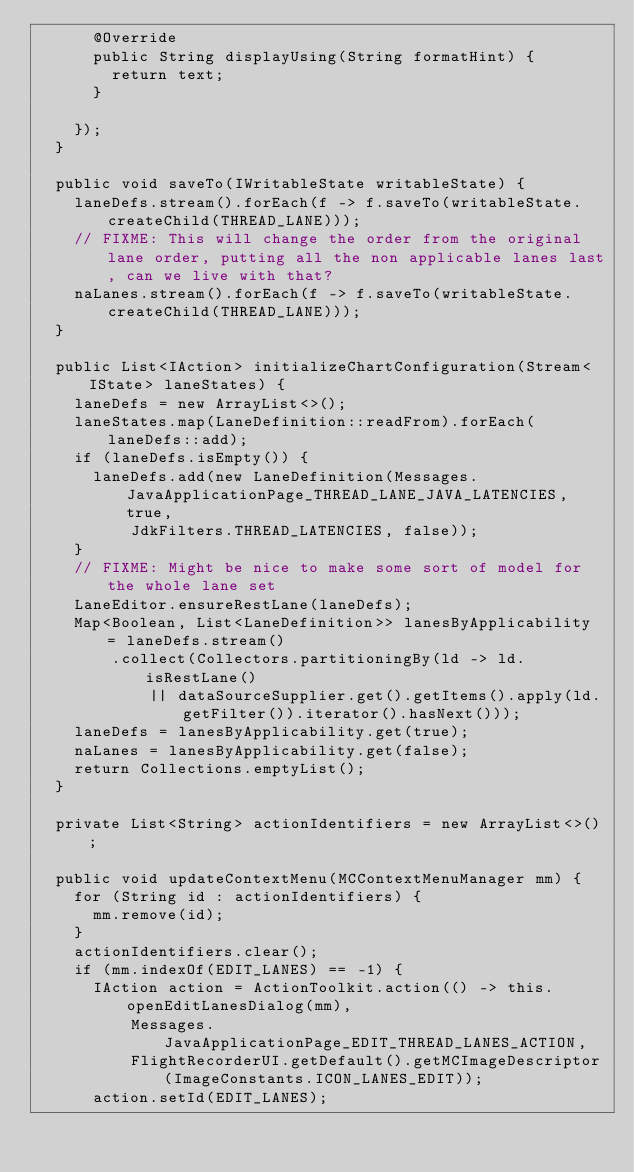<code> <loc_0><loc_0><loc_500><loc_500><_Java_>			@Override
			public String displayUsing(String formatHint) {
				return text;
			}

		});
	}

	public void saveTo(IWritableState writableState) {
		laneDefs.stream().forEach(f -> f.saveTo(writableState.createChild(THREAD_LANE)));
		// FIXME: This will change the order from the original lane order, putting all the non applicable lanes last, can we live with that?
		naLanes.stream().forEach(f -> f.saveTo(writableState.createChild(THREAD_LANE)));
	}

	public List<IAction> initializeChartConfiguration(Stream<IState> laneStates) {
		laneDefs = new ArrayList<>();
		laneStates.map(LaneDefinition::readFrom).forEach(laneDefs::add);
		if (laneDefs.isEmpty()) {
			laneDefs.add(new LaneDefinition(Messages.JavaApplicationPage_THREAD_LANE_JAVA_LATENCIES, true,
					JdkFilters.THREAD_LATENCIES, false));
		}
		// FIXME: Might be nice to make some sort of model for the whole lane set
		LaneEditor.ensureRestLane(laneDefs);
		Map<Boolean, List<LaneDefinition>> lanesByApplicability = laneDefs.stream()
				.collect(Collectors.partitioningBy(ld -> ld.isRestLane()
						|| dataSourceSupplier.get().getItems().apply(ld.getFilter()).iterator().hasNext()));
		laneDefs = lanesByApplicability.get(true);
		naLanes = lanesByApplicability.get(false);
		return Collections.emptyList();
	}

	private List<String> actionIdentifiers = new ArrayList<>();

	public void updateContextMenu(MCContextMenuManager mm) {
		for (String id : actionIdentifiers) {
			mm.remove(id);
		}
		actionIdentifiers.clear();
		if (mm.indexOf(EDIT_LANES) == -1) {
			IAction action = ActionToolkit.action(() -> this.openEditLanesDialog(mm),
					Messages.JavaApplicationPage_EDIT_THREAD_LANES_ACTION,
					FlightRecorderUI.getDefault().getMCImageDescriptor(ImageConstants.ICON_LANES_EDIT));
			action.setId(EDIT_LANES);</code> 